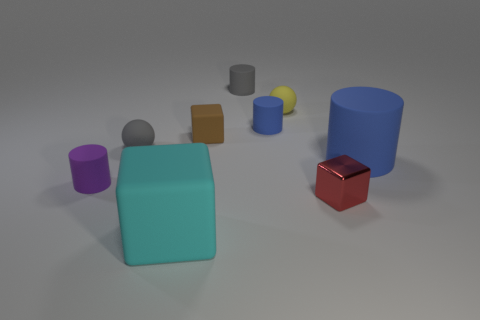Subtract all brown cylinders. Subtract all gray balls. How many cylinders are left? 4 Subtract all blocks. How many objects are left? 6 Add 5 small rubber cylinders. How many small rubber cylinders exist? 8 Subtract 0 green cylinders. How many objects are left? 9 Subtract all tiny yellow matte cubes. Subtract all tiny red metal cubes. How many objects are left? 8 Add 7 blocks. How many blocks are left? 10 